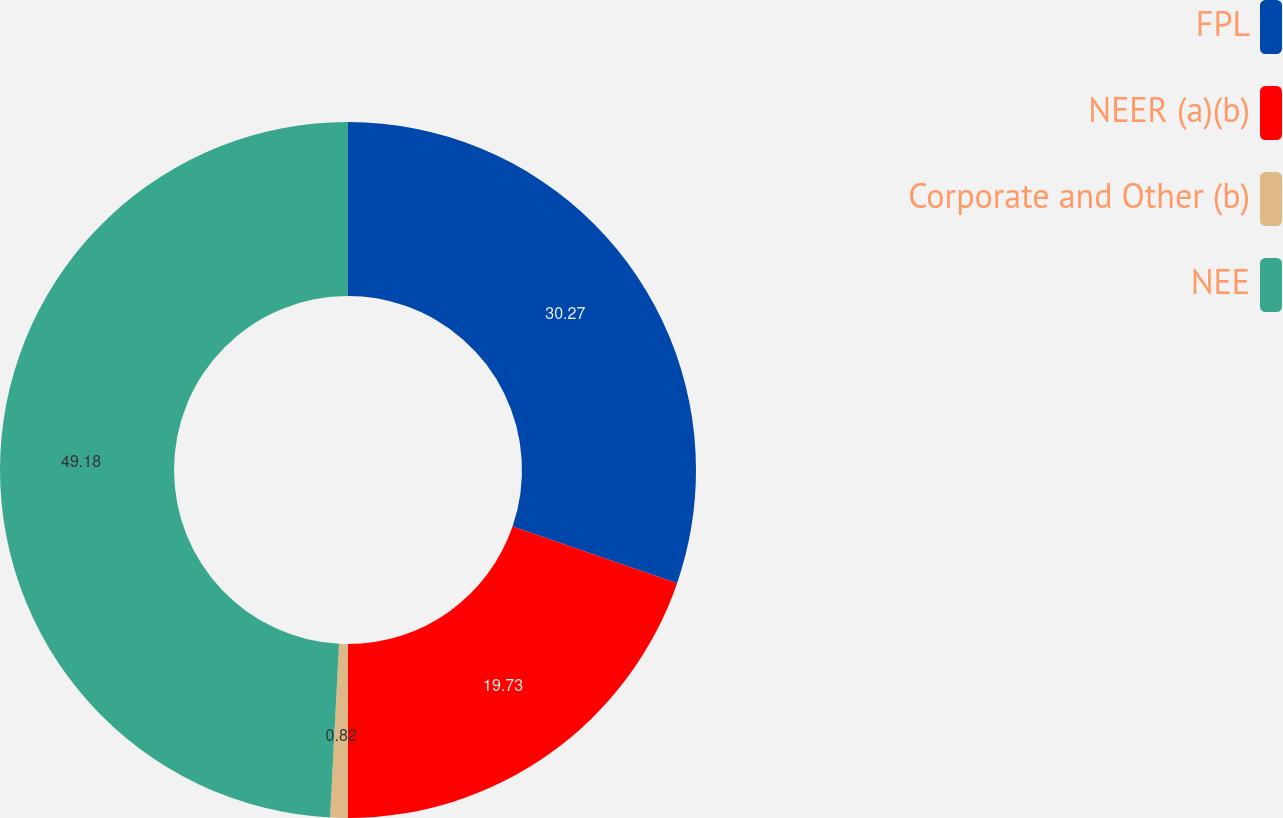<chart> <loc_0><loc_0><loc_500><loc_500><pie_chart><fcel>FPL<fcel>NEER (a)(b)<fcel>Corporate and Other (b)<fcel>NEE<nl><fcel>30.27%<fcel>19.73%<fcel>0.82%<fcel>49.18%<nl></chart> 